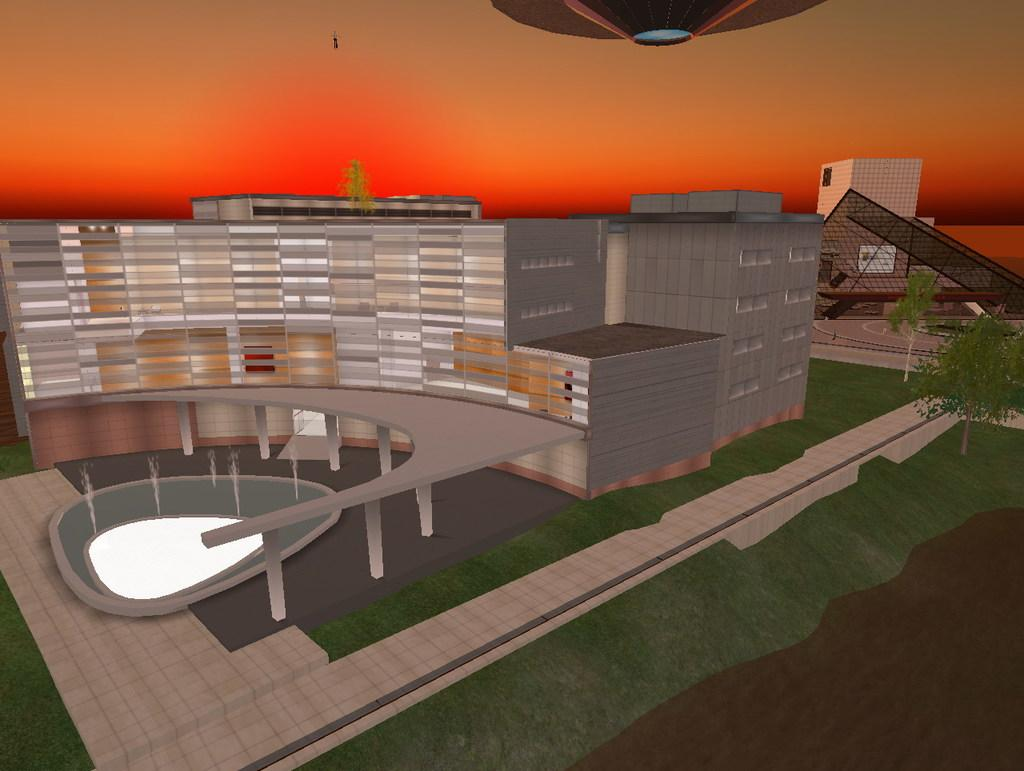What type of structures can be seen in the image? There are buildings in the image. What other natural elements are present in the image? There are trees in the image. What part of the environment is visible in the image? The sky is visible in the image. What type of spade is being used to dig up the things in the image? There is no spade or digging activity present in the image. 